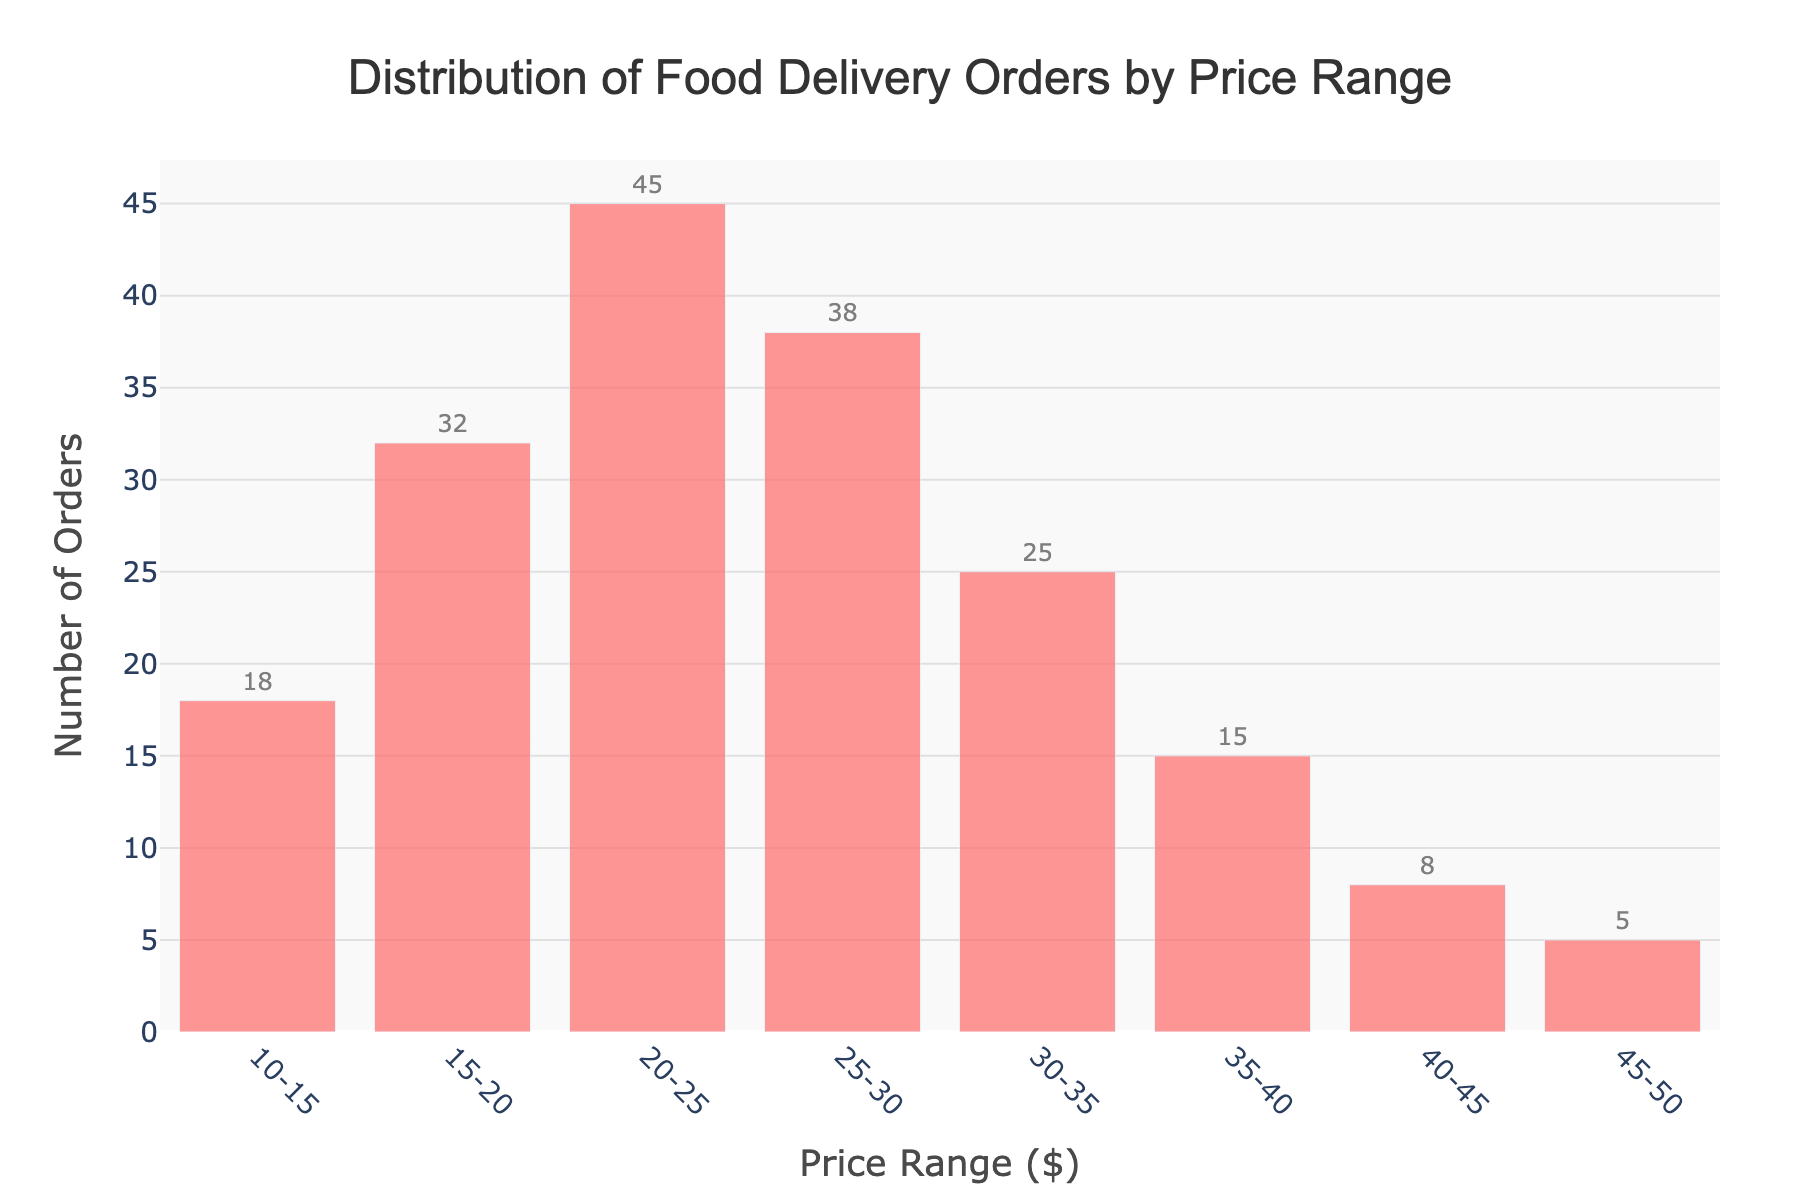What is the title of the figure? The title of the figure is located at the top, providing a summary of what the figure represents.
Answer: Distribution of Food Delivery Orders by Price Range Which price range has the highest number of orders? Identify the bar with the highest value on the y-axis. This bar's x-axis label corresponds to the price range with the most orders.
Answer: 20-25 How many price ranges are displayed in the figure? Count the distinct bars on the x-axis which represent different price ranges.
Answer: 8 What is the number of orders for the price range $35-40? Locate the bar corresponding to the price range $35-40 on the x-axis and find its height on the y-axis.
Answer: 15 What's the difference in the number of orders between the price ranges $20-25 and $15-20? Identify the number of orders for both price ranges and subtract the smaller value from the larger one. 45 - 32
Answer: 13 Which price range has the least number of orders? Identify the shortest bar on the histogram and find its corresponding price range on the x-axis.
Answer: 45-50 What is the total number of orders for price ranges below $30? Sum the number of orders for all bars that represent price ranges less than $30. 18 + 32 + 45 + 38
Answer: 133 Which price range shows a decline in the number of orders compared to the previous range? Examine each adjacent pair of bars to see where the height decreases from one bar to the next. The $25-30 to $30-35 range is an example. 38 to 25
Answer: 30-35 Are there more orders in the $20-25 range than in the $10-15 and $40-45 ranges combined? Compare the number of orders in the $20-25 range with the sum of the $10-15 and $40-45 ranges. 45 vs. 18 + 8
Answer: Yes What is the average number of orders across all price ranges? Add together the number of orders for all price ranges and divide by the number of ranges. (18 + 32 + 45 + 38 + 25 + 15 + 8 + 5) / 8 = 186 / 8
Answer: 23.25 